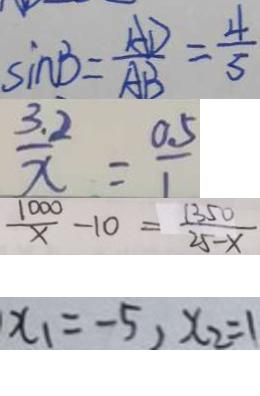Convert formula to latex. <formula><loc_0><loc_0><loc_500><loc_500>\sin B = \frac { A D } { A B } = \frac { 4 } { 5 } 
 \frac { 3 . 2 } { x } = \frac { 0 . 5 } { 1 } 
 \frac { 1 0 0 0 } { x } - 1 0 = \frac { 1 3 5 0 } { 2 5 - x } 
 x _ { 1 } = - 5 , x _ { 2 } = 1</formula> 